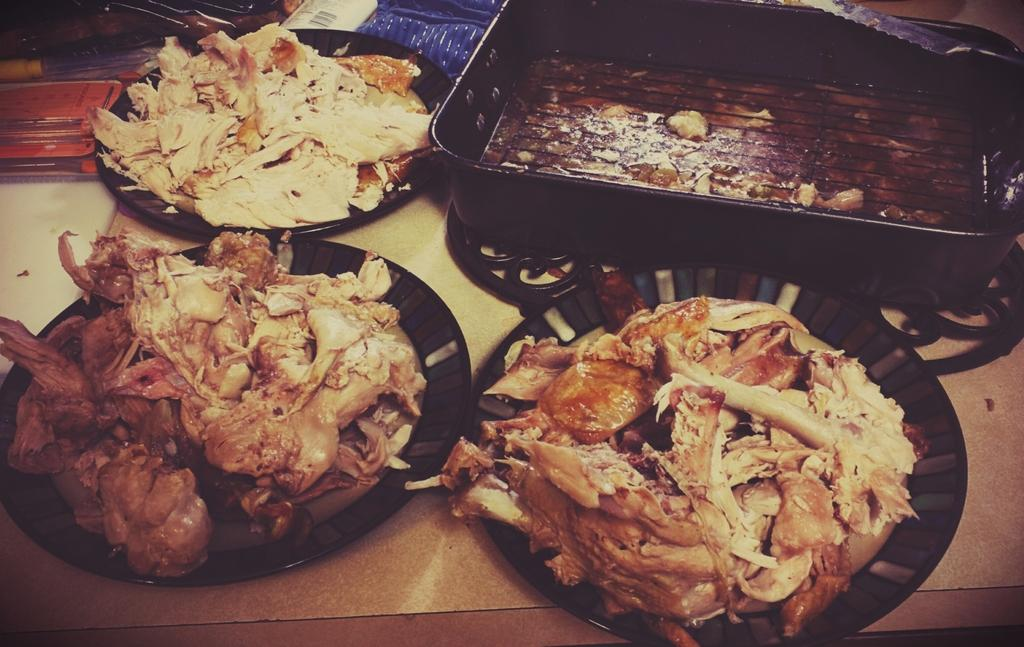What piece of furniture is present in the image? There is a table in the image. What is placed on the table? There are bowls on the table. What is inside the bowls? There is meat in the bowls. Where is the goose located in the image? There is no goose present in the image. What type of oven is used to cook the meat in the image? There is no oven present in the image, and the cooking method for the meat is not mentioned. 